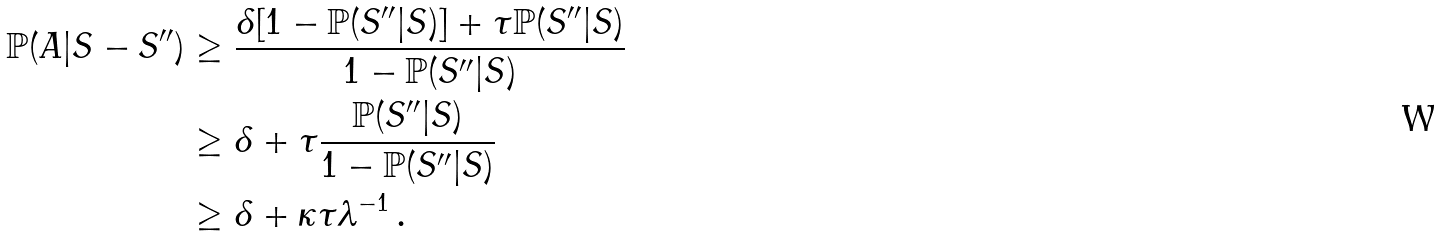Convert formula to latex. <formula><loc_0><loc_0><loc_500><loc_500>\mathbb { P } ( A | S - S ^ { \prime \prime } ) & \geq \frac { \delta [ 1 - \mathbb { P } ( S ^ { \prime \prime } | S ) ] + \tau \mathbb { P } ( S ^ { \prime \prime } | S ) } { 1 - \mathbb { P } ( S ^ { \prime \prime } | S ) } \\ & \geq \delta + \tau \frac { \mathbb { P } ( S ^ { \prime \prime } | S ) } { 1 - \mathbb { P } ( S ^ { \prime \prime } | S ) } \\ & \geq \delta + \kappa \tau \lambda ^ { - 1 } \, .</formula> 